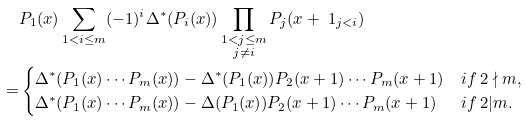Convert formula to latex. <formula><loc_0><loc_0><loc_500><loc_500>& P _ { 1 } ( x ) \sum _ { 1 < i \leq m } ( - 1 ) ^ { i } \Delta ^ { * } ( P _ { i } ( x ) ) \prod _ { \substack { 1 < j \leq m \\ j \not = i } } P _ { j } ( x + \ 1 _ { j < i } ) \\ = & \begin{cases} \Delta ^ { * } ( P _ { 1 } ( x ) \cdots P _ { m } ( x ) ) - \Delta ^ { * } ( P _ { 1 } ( x ) ) P _ { 2 } ( x + 1 ) \cdots P _ { m } ( x + 1 ) & i f \ 2 \nmid m , \\ \Delta ^ { * } ( P _ { 1 } ( x ) \cdots P _ { m } ( x ) ) - \Delta ( P _ { 1 } ( x ) ) P _ { 2 } ( x + 1 ) \cdots P _ { m } ( x + 1 ) & i f \ 2 | m . \end{cases}</formula> 